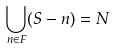Convert formula to latex. <formula><loc_0><loc_0><loc_500><loc_500>\bigcup _ { n \in F } ( S - n ) = N</formula> 